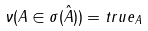Convert formula to latex. <formula><loc_0><loc_0><loc_500><loc_500>\nu ( A \in \sigma ( \hat { A } ) ) = t r u e _ { A }</formula> 